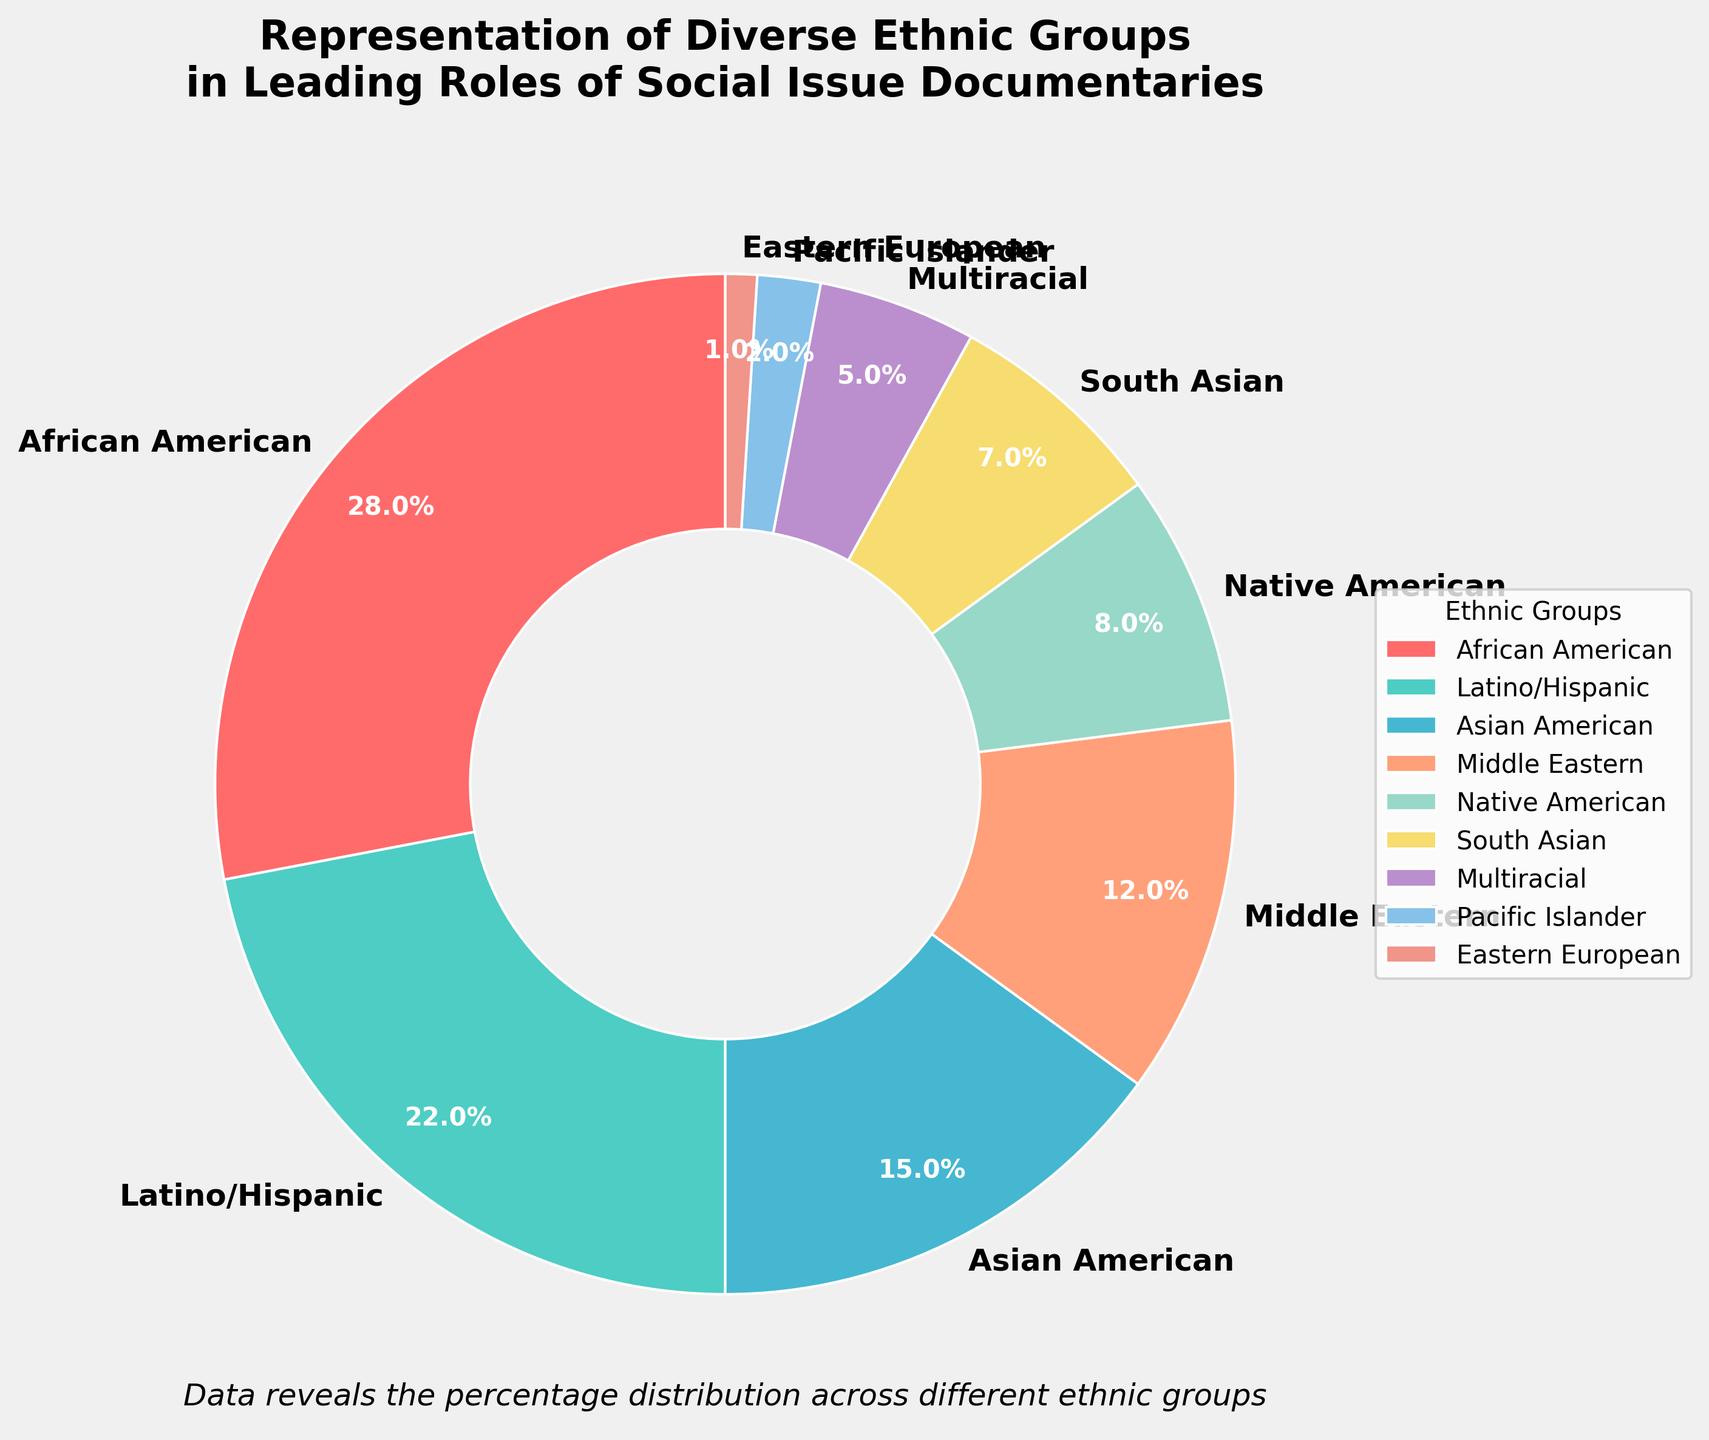What is the percentage of African American representation in leading roles? The figure shows a pie chart with percentages labeled for each ethnic group. Find the label corresponding to African American and note the percentage.
Answer: 28% Which ethnic group has the lowest representation in leading roles? Examine the pie chart and identify the ethnic group with the smallest percentage.
Answer: Eastern European Is the representation of Middle Eastern and South Asian groups combined greater than Latino/Hispanic representation? Add Middle Eastern's 12% and South Asian's 7%, then compare their sum (19%) with Latino/Hispanic's 22%.
Answer: No What is the difference in percentage representation between the group with the highest and the group with the lowest representation? Identify the highest percentage (African American, 28%) and the lowest percentage (Eastern European, 1%). Subtract the lowest from the highest: 28% - 1% = 27%.
Answer: 27% What is the total percentage representation of African American, Latino/Hispanic, and Asian American groups combined? Add the percentages of African American (28%), Latino/Hispanic (22%), and Asian American (15%): 28% + 22% + 15% = 65%.
Answer: 65% How many groups have a representation of less than 10%? Identify the ethnic groups with percentages less than 10%: Native American (8%), South Asian (7%), Multiracial (5%), Pacific Islander (2%), Eastern European (1%). Count the number of groups: 5.
Answer: 5 Which ethnic group is represented by the color green in the chart? Identify the color green on the pie chart and match it to the corresponding ethnic group label.
Answer: Latino/Hispanic Compare the representation of Native American and Multiracial groups. Which is greater and by how much? Locate the percentages for Native American (8%) and Multiracial (5%). Subtract Multiracial's percentage from Native American's: 8% - 5% = 3%.
Answer: Native American by 3% Is the combined percentage of Multiracial and Pacific Islander groups equal to the percentage of Asian American representation? Add Multiracial's 5% and Pacific Islander's 2%, then compare their sum (7%) to Asian American's 15%.
Answer: No What is the average percentage representation of all the ethnic groups listed? Add all the percentages together: 28 + 22 + 15 + 12 + 8 + 7 + 5 + 2 + 1 = 100. Divide by the number of ethnic groups (9): 100 / 9 ≈ 11.11%.
Answer: 11.11% 